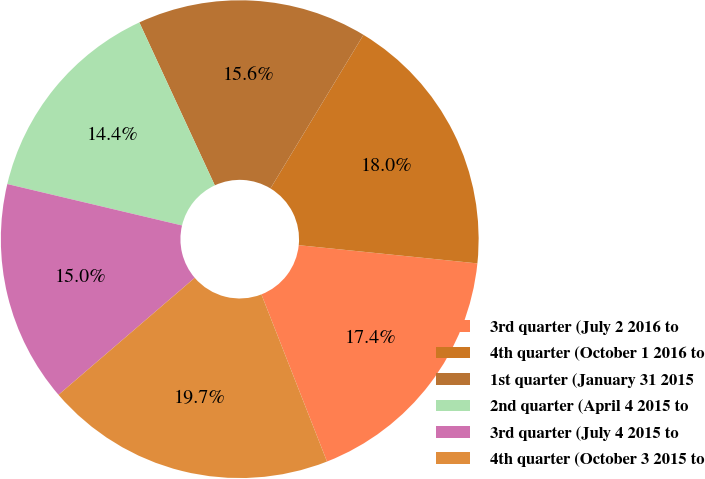<chart> <loc_0><loc_0><loc_500><loc_500><pie_chart><fcel>3rd quarter (July 2 2016 to<fcel>4th quarter (October 1 2016 to<fcel>1st quarter (January 31 2015<fcel>2nd quarter (April 4 2015 to<fcel>3rd quarter (July 4 2015 to<fcel>4th quarter (October 3 2015 to<nl><fcel>17.43%<fcel>17.95%<fcel>15.57%<fcel>14.39%<fcel>15.0%<fcel>19.66%<nl></chart> 